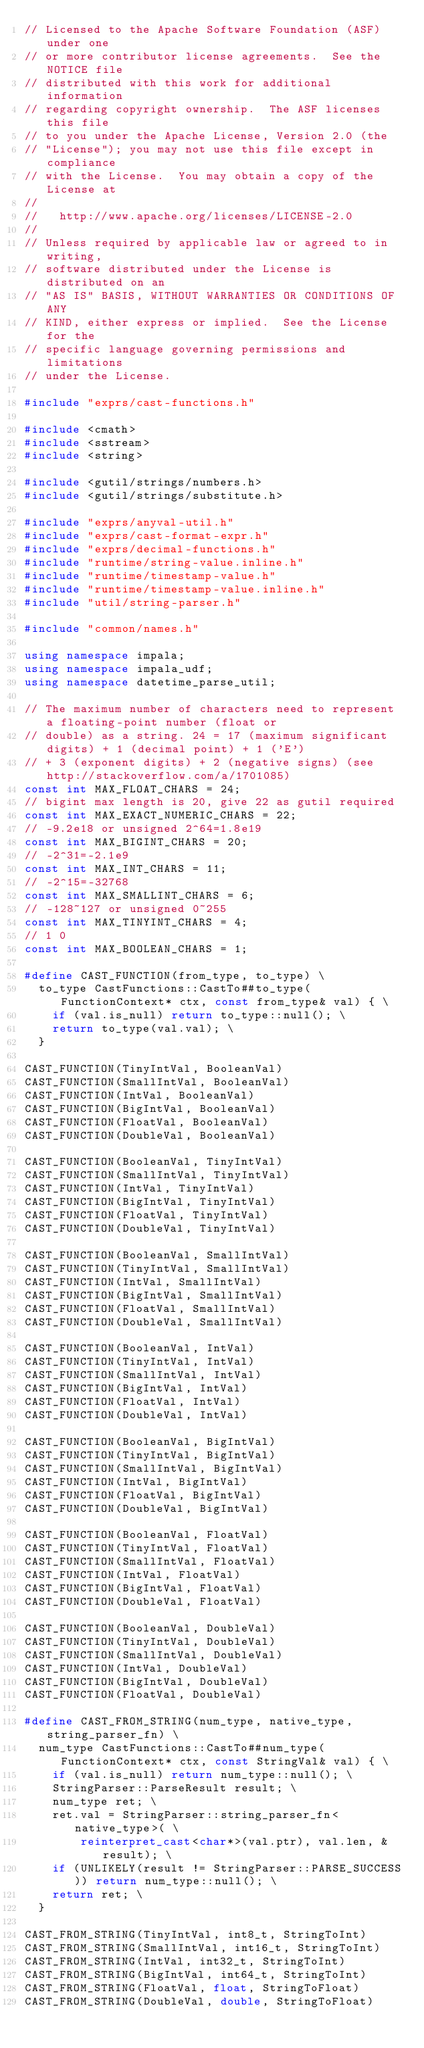<code> <loc_0><loc_0><loc_500><loc_500><_C++_>// Licensed to the Apache Software Foundation (ASF) under one
// or more contributor license agreements.  See the NOTICE file
// distributed with this work for additional information
// regarding copyright ownership.  The ASF licenses this file
// to you under the Apache License, Version 2.0 (the
// "License"); you may not use this file except in compliance
// with the License.  You may obtain a copy of the License at
//
//   http://www.apache.org/licenses/LICENSE-2.0
//
// Unless required by applicable law or agreed to in writing,
// software distributed under the License is distributed on an
// "AS IS" BASIS, WITHOUT WARRANTIES OR CONDITIONS OF ANY
// KIND, either express or implied.  See the License for the
// specific language governing permissions and limitations
// under the License.

#include "exprs/cast-functions.h"

#include <cmath>
#include <sstream>
#include <string>

#include <gutil/strings/numbers.h>
#include <gutil/strings/substitute.h>

#include "exprs/anyval-util.h"
#include "exprs/cast-format-expr.h"
#include "exprs/decimal-functions.h"
#include "runtime/string-value.inline.h"
#include "runtime/timestamp-value.h"
#include "runtime/timestamp-value.inline.h"
#include "util/string-parser.h"

#include "common/names.h"

using namespace impala;
using namespace impala_udf;
using namespace datetime_parse_util;

// The maximum number of characters need to represent a floating-point number (float or
// double) as a string. 24 = 17 (maximum significant digits) + 1 (decimal point) + 1 ('E')
// + 3 (exponent digits) + 2 (negative signs) (see http://stackoverflow.com/a/1701085)
const int MAX_FLOAT_CHARS = 24;
// bigint max length is 20, give 22 as gutil required
const int MAX_EXACT_NUMERIC_CHARS = 22;
// -9.2e18 or unsigned 2^64=1.8e19
const int MAX_BIGINT_CHARS = 20;
// -2^31=-2.1e9
const int MAX_INT_CHARS = 11;
// -2^15=-32768
const int MAX_SMALLINT_CHARS = 6;
// -128~127 or unsigned 0~255
const int MAX_TINYINT_CHARS = 4;
// 1 0
const int MAX_BOOLEAN_CHARS = 1;

#define CAST_FUNCTION(from_type, to_type) \
  to_type CastFunctions::CastTo##to_type(FunctionContext* ctx, const from_type& val) { \
    if (val.is_null) return to_type::null(); \
    return to_type(val.val); \
  }

CAST_FUNCTION(TinyIntVal, BooleanVal)
CAST_FUNCTION(SmallIntVal, BooleanVal)
CAST_FUNCTION(IntVal, BooleanVal)
CAST_FUNCTION(BigIntVal, BooleanVal)
CAST_FUNCTION(FloatVal, BooleanVal)
CAST_FUNCTION(DoubleVal, BooleanVal)

CAST_FUNCTION(BooleanVal, TinyIntVal)
CAST_FUNCTION(SmallIntVal, TinyIntVal)
CAST_FUNCTION(IntVal, TinyIntVal)
CAST_FUNCTION(BigIntVal, TinyIntVal)
CAST_FUNCTION(FloatVal, TinyIntVal)
CAST_FUNCTION(DoubleVal, TinyIntVal)

CAST_FUNCTION(BooleanVal, SmallIntVal)
CAST_FUNCTION(TinyIntVal, SmallIntVal)
CAST_FUNCTION(IntVal, SmallIntVal)
CAST_FUNCTION(BigIntVal, SmallIntVal)
CAST_FUNCTION(FloatVal, SmallIntVal)
CAST_FUNCTION(DoubleVal, SmallIntVal)

CAST_FUNCTION(BooleanVal, IntVal)
CAST_FUNCTION(TinyIntVal, IntVal)
CAST_FUNCTION(SmallIntVal, IntVal)
CAST_FUNCTION(BigIntVal, IntVal)
CAST_FUNCTION(FloatVal, IntVal)
CAST_FUNCTION(DoubleVal, IntVal)

CAST_FUNCTION(BooleanVal, BigIntVal)
CAST_FUNCTION(TinyIntVal, BigIntVal)
CAST_FUNCTION(SmallIntVal, BigIntVal)
CAST_FUNCTION(IntVal, BigIntVal)
CAST_FUNCTION(FloatVal, BigIntVal)
CAST_FUNCTION(DoubleVal, BigIntVal)

CAST_FUNCTION(BooleanVal, FloatVal)
CAST_FUNCTION(TinyIntVal, FloatVal)
CAST_FUNCTION(SmallIntVal, FloatVal)
CAST_FUNCTION(IntVal, FloatVal)
CAST_FUNCTION(BigIntVal, FloatVal)
CAST_FUNCTION(DoubleVal, FloatVal)

CAST_FUNCTION(BooleanVal, DoubleVal)
CAST_FUNCTION(TinyIntVal, DoubleVal)
CAST_FUNCTION(SmallIntVal, DoubleVal)
CAST_FUNCTION(IntVal, DoubleVal)
CAST_FUNCTION(BigIntVal, DoubleVal)
CAST_FUNCTION(FloatVal, DoubleVal)

#define CAST_FROM_STRING(num_type, native_type, string_parser_fn) \
  num_type CastFunctions::CastTo##num_type(FunctionContext* ctx, const StringVal& val) { \
    if (val.is_null) return num_type::null(); \
    StringParser::ParseResult result; \
    num_type ret; \
    ret.val = StringParser::string_parser_fn<native_type>( \
        reinterpret_cast<char*>(val.ptr), val.len, &result); \
    if (UNLIKELY(result != StringParser::PARSE_SUCCESS)) return num_type::null(); \
    return ret; \
  }

CAST_FROM_STRING(TinyIntVal, int8_t, StringToInt)
CAST_FROM_STRING(SmallIntVal, int16_t, StringToInt)
CAST_FROM_STRING(IntVal, int32_t, StringToInt)
CAST_FROM_STRING(BigIntVal, int64_t, StringToInt)
CAST_FROM_STRING(FloatVal, float, StringToFloat)
CAST_FROM_STRING(DoubleVal, double, StringToFloat)

</code> 